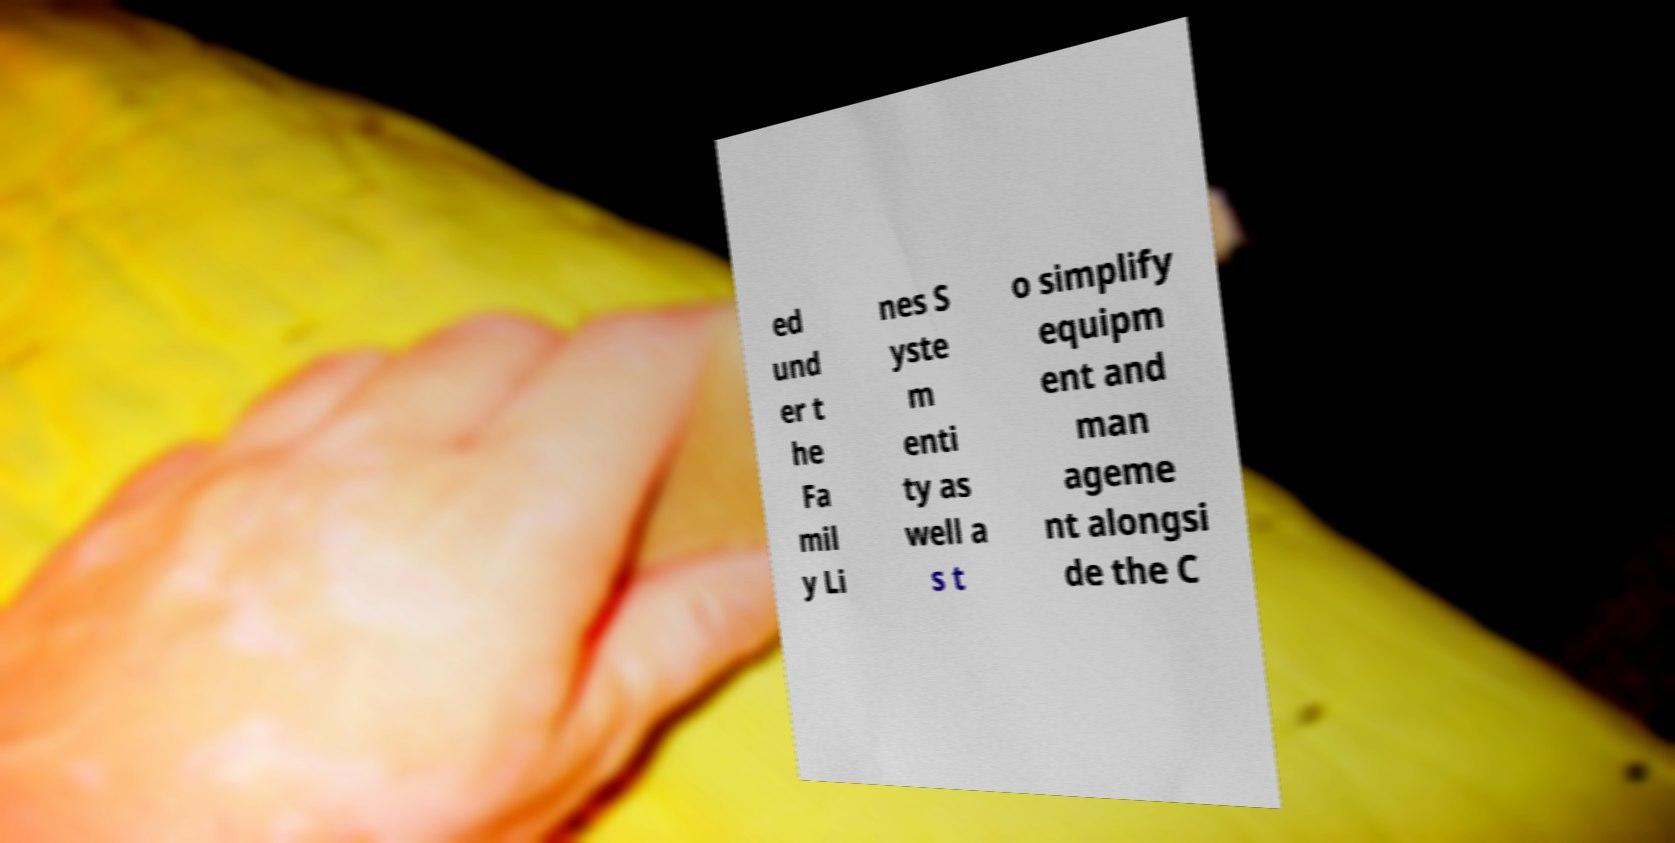Could you extract and type out the text from this image? ed und er t he Fa mil y Li nes S yste m enti ty as well a s t o simplify equipm ent and man ageme nt alongsi de the C 